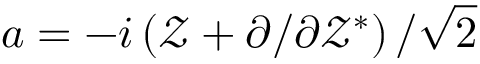<formula> <loc_0><loc_0><loc_500><loc_500>a = - { i } \left ( \mathcal { Z } + { \partial } / { \partial \mathcal { Z } ^ { * } } \right ) / { \sqrt { 2 } }</formula> 